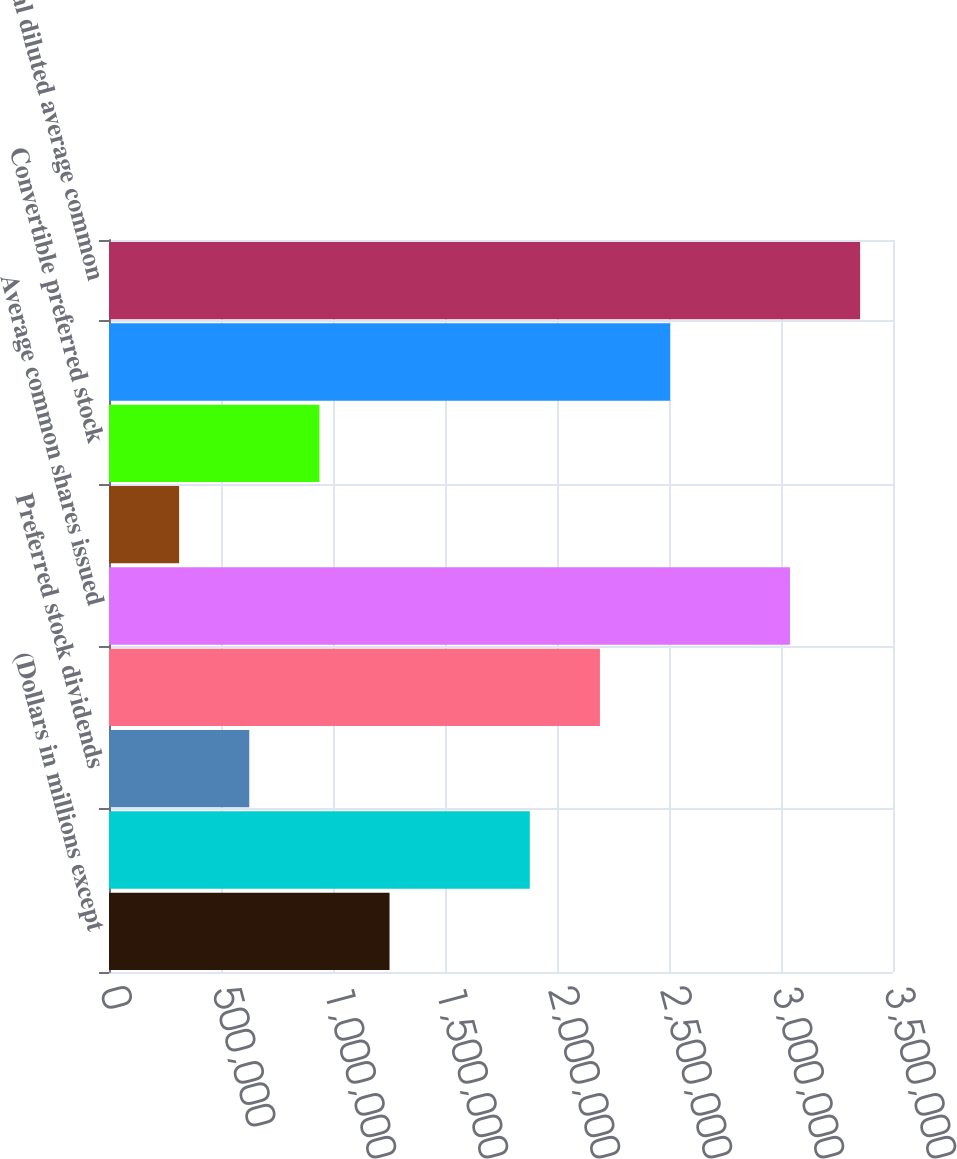<chart> <loc_0><loc_0><loc_500><loc_500><bar_chart><fcel>(Dollars in millions except<fcel>Net income<fcel>Preferred stock dividends<fcel>Net income available to common<fcel>Average common shares issued<fcel>Earnings per common share<fcel>Convertible preferred stock<fcel>Dilutive potential common<fcel>Total diluted average common<nl><fcel>1.25238e+06<fcel>1.87856e+06<fcel>626189<fcel>2.19166e+06<fcel>3.04008e+06<fcel>313096<fcel>939283<fcel>2.50475e+06<fcel>3.35318e+06<nl></chart> 